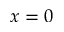Convert formula to latex. <formula><loc_0><loc_0><loc_500><loc_500>x = 0</formula> 